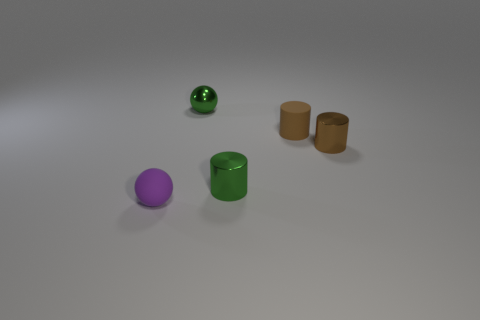Subtract all gray cylinders. Subtract all purple balls. How many cylinders are left? 3 Add 4 tiny metallic cylinders. How many objects exist? 9 Subtract all cylinders. How many objects are left? 2 Subtract all tiny green cylinders. Subtract all purple balls. How many objects are left? 3 Add 2 green shiny objects. How many green shiny objects are left? 4 Add 3 green things. How many green things exist? 5 Subtract 0 cyan cubes. How many objects are left? 5 